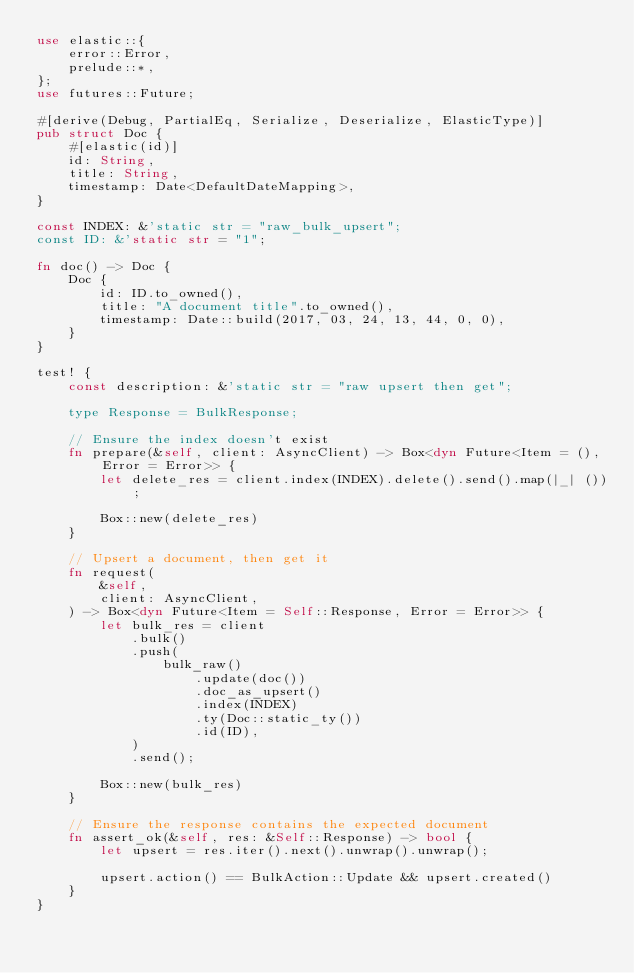<code> <loc_0><loc_0><loc_500><loc_500><_Rust_>use elastic::{
    error::Error,
    prelude::*,
};
use futures::Future;

#[derive(Debug, PartialEq, Serialize, Deserialize, ElasticType)]
pub struct Doc {
    #[elastic(id)]
    id: String,
    title: String,
    timestamp: Date<DefaultDateMapping>,
}

const INDEX: &'static str = "raw_bulk_upsert";
const ID: &'static str = "1";

fn doc() -> Doc {
    Doc {
        id: ID.to_owned(),
        title: "A document title".to_owned(),
        timestamp: Date::build(2017, 03, 24, 13, 44, 0, 0),
    }
}

test! {
    const description: &'static str = "raw upsert then get";

    type Response = BulkResponse;

    // Ensure the index doesn't exist
    fn prepare(&self, client: AsyncClient) -> Box<dyn Future<Item = (), Error = Error>> {
        let delete_res = client.index(INDEX).delete().send().map(|_| ());

        Box::new(delete_res)
    }

    // Upsert a document, then get it
    fn request(
        &self,
        client: AsyncClient,
    ) -> Box<dyn Future<Item = Self::Response, Error = Error>> {
        let bulk_res = client
            .bulk()
            .push(
                bulk_raw()
                    .update(doc())
                    .doc_as_upsert()
                    .index(INDEX)
                    .ty(Doc::static_ty())
                    .id(ID),
            )
            .send();

        Box::new(bulk_res)
    }

    // Ensure the response contains the expected document
    fn assert_ok(&self, res: &Self::Response) -> bool {
        let upsert = res.iter().next().unwrap().unwrap();

        upsert.action() == BulkAction::Update && upsert.created()
    }
}
</code> 